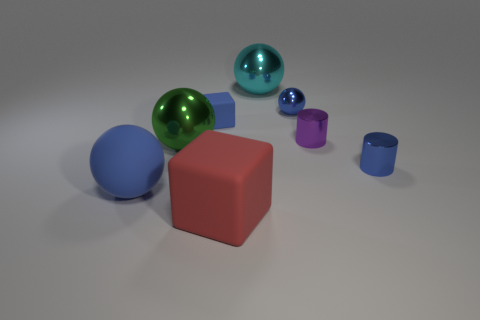Subtract all large cyan metallic spheres. How many spheres are left? 3 Add 1 large green balls. How many objects exist? 9 Subtract 2 blocks. How many blocks are left? 0 Subtract all green balls. How many balls are left? 3 Subtract all cubes. How many objects are left? 6 Subtract all brown cylinders. Subtract all brown blocks. How many cylinders are left? 2 Subtract all red balls. How many blue cylinders are left? 1 Subtract all red matte things. Subtract all cyan metal objects. How many objects are left? 6 Add 1 metallic spheres. How many metallic spheres are left? 4 Add 4 tiny red metallic things. How many tiny red metallic things exist? 4 